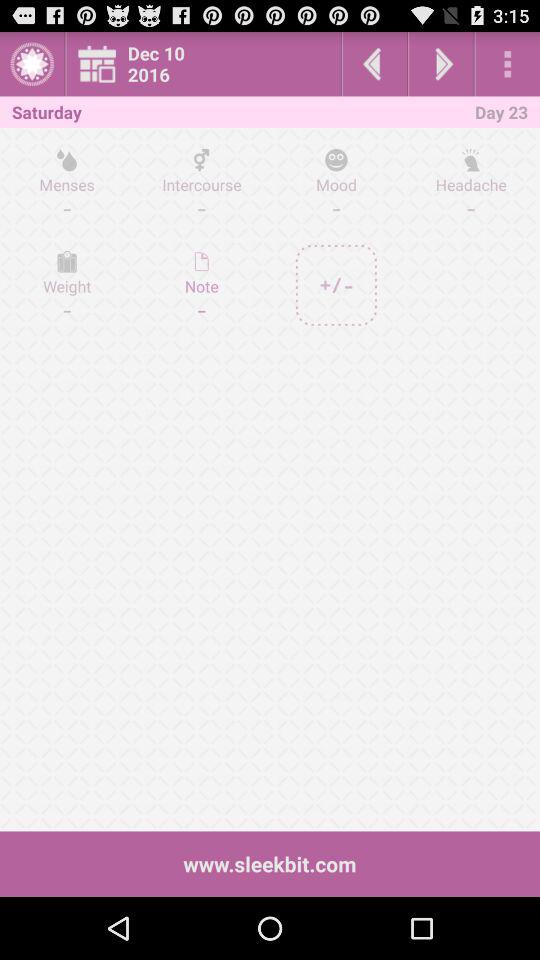What is the day on Dec. 10, 2016? The day is Saturday. 